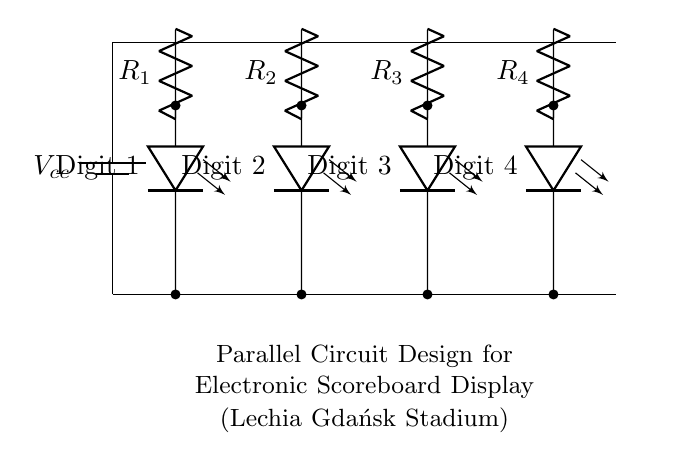What type of circuit is shown in the diagram? The circuit design is a parallel circuit, as multiple components are connected across the same two nodes or power supply, allowing them to operate independently of each other.
Answer: Parallel circuit How many LED arrays are present in this design? The diagram shows four LED arrays, each representing a digit for the scoreboard, indicated as Digit 1, Digit 2, Digit 3, and Digit 4.
Answer: Four What is the purpose of the resistors in this circuit? The resistors limit the current flowing through each LED array, preventing them from drawing too much current and potentially burning out.
Answer: Current limiting What is the role of the power supply represented in the diagram? The power supply provides the necessary voltage to the circuit, ensuring that all components receive adequate power to function.
Answer: Voltage source If one LED fails, how will it affect the other LEDs in this circuit? Since it's a parallel circuit, the operation of other LEDs will remain unaffected; each LED has its path to the power supply.
Answer: Unaffected What happens to the total current drawn from the power supply as more LEDs are added? In a parallel circuit configuration, the total current increases as each new LED provides an additional path for current flow.
Answer: Increases What is the voltage supplied across each LED in this configuration? The voltage is the same across all components in a parallel circuit; therefore, the voltage across each LED is equal to the supply voltage 'Vcc.'
Answer: Vcc 